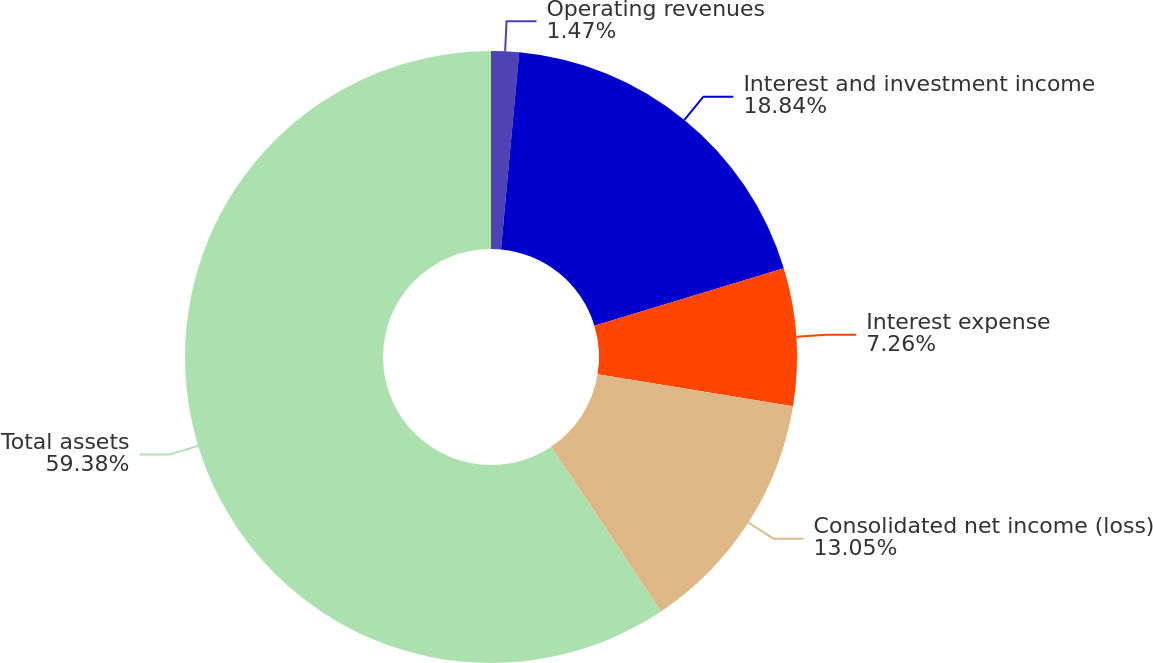Convert chart. <chart><loc_0><loc_0><loc_500><loc_500><pie_chart><fcel>Operating revenues<fcel>Interest and investment income<fcel>Interest expense<fcel>Consolidated net income (loss)<fcel>Total assets<nl><fcel>1.47%<fcel>18.84%<fcel>7.26%<fcel>13.05%<fcel>59.38%<nl></chart> 